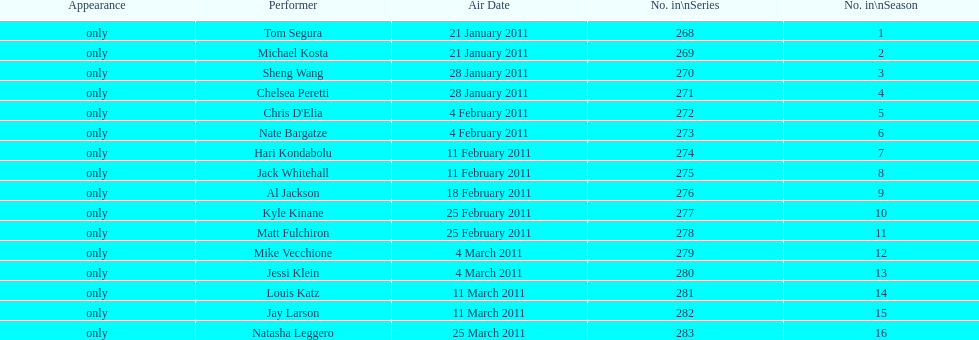What were the total number of air dates in february? 7. 